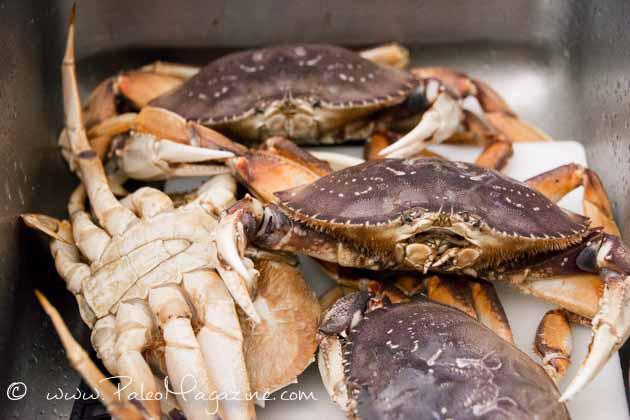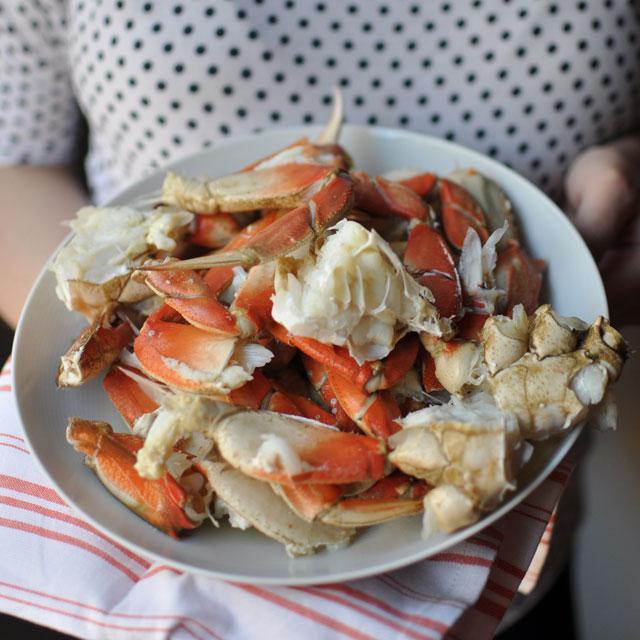The first image is the image on the left, the second image is the image on the right. For the images shown, is this caption "There is a single package of two crabs in an image." true? Answer yes or no. No. The first image is the image on the left, the second image is the image on the right. Given the left and right images, does the statement "In at least one image there is a total two crabs wrap in a single blue and plastic container." hold true? Answer yes or no. No. 